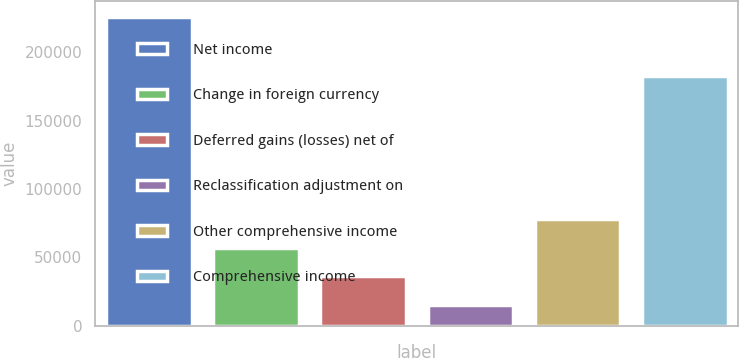Convert chart. <chart><loc_0><loc_0><loc_500><loc_500><bar_chart><fcel>Net income<fcel>Change in foreign currency<fcel>Deferred gains (losses) net of<fcel>Reclassification adjustment on<fcel>Other comprehensive income<fcel>Comprehensive income<nl><fcel>225934<fcel>57125.2<fcel>36024.1<fcel>14923<fcel>78226.3<fcel>182648<nl></chart> 